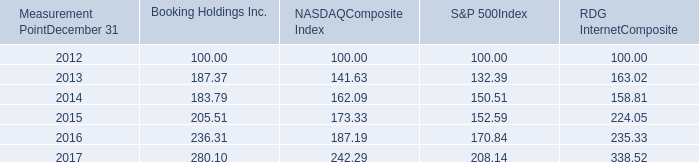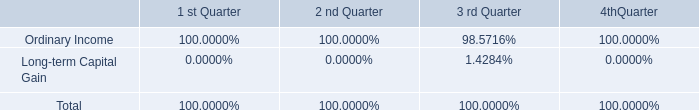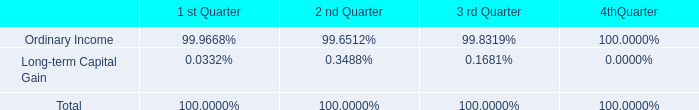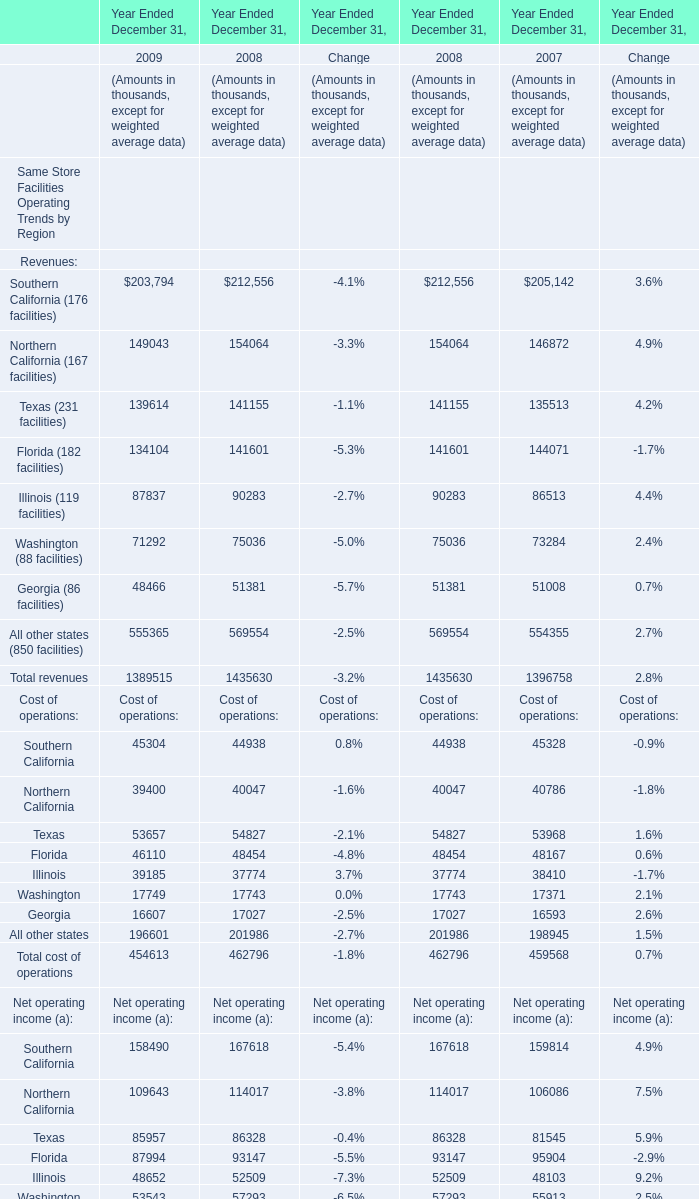Does Southern California keeps increasing each year between 2008 and 2009? 
Answer: yes. 